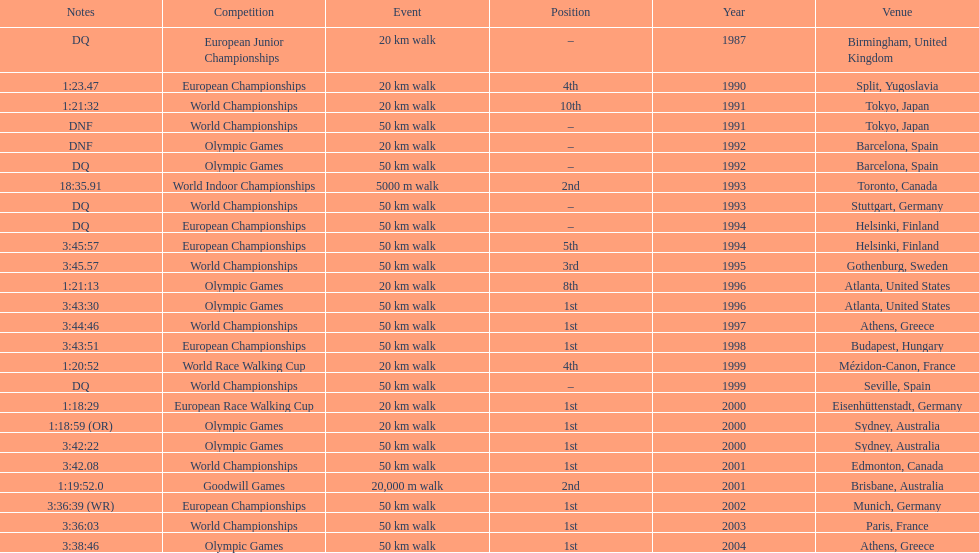In what year was korzeniowski's last competition? 2004. 